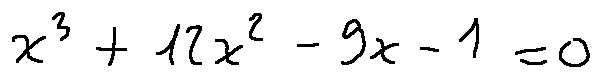<formula> <loc_0><loc_0><loc_500><loc_500>x ^ { 3 } + 1 2 x ^ { 2 } - 9 x - 1 = 0</formula> 